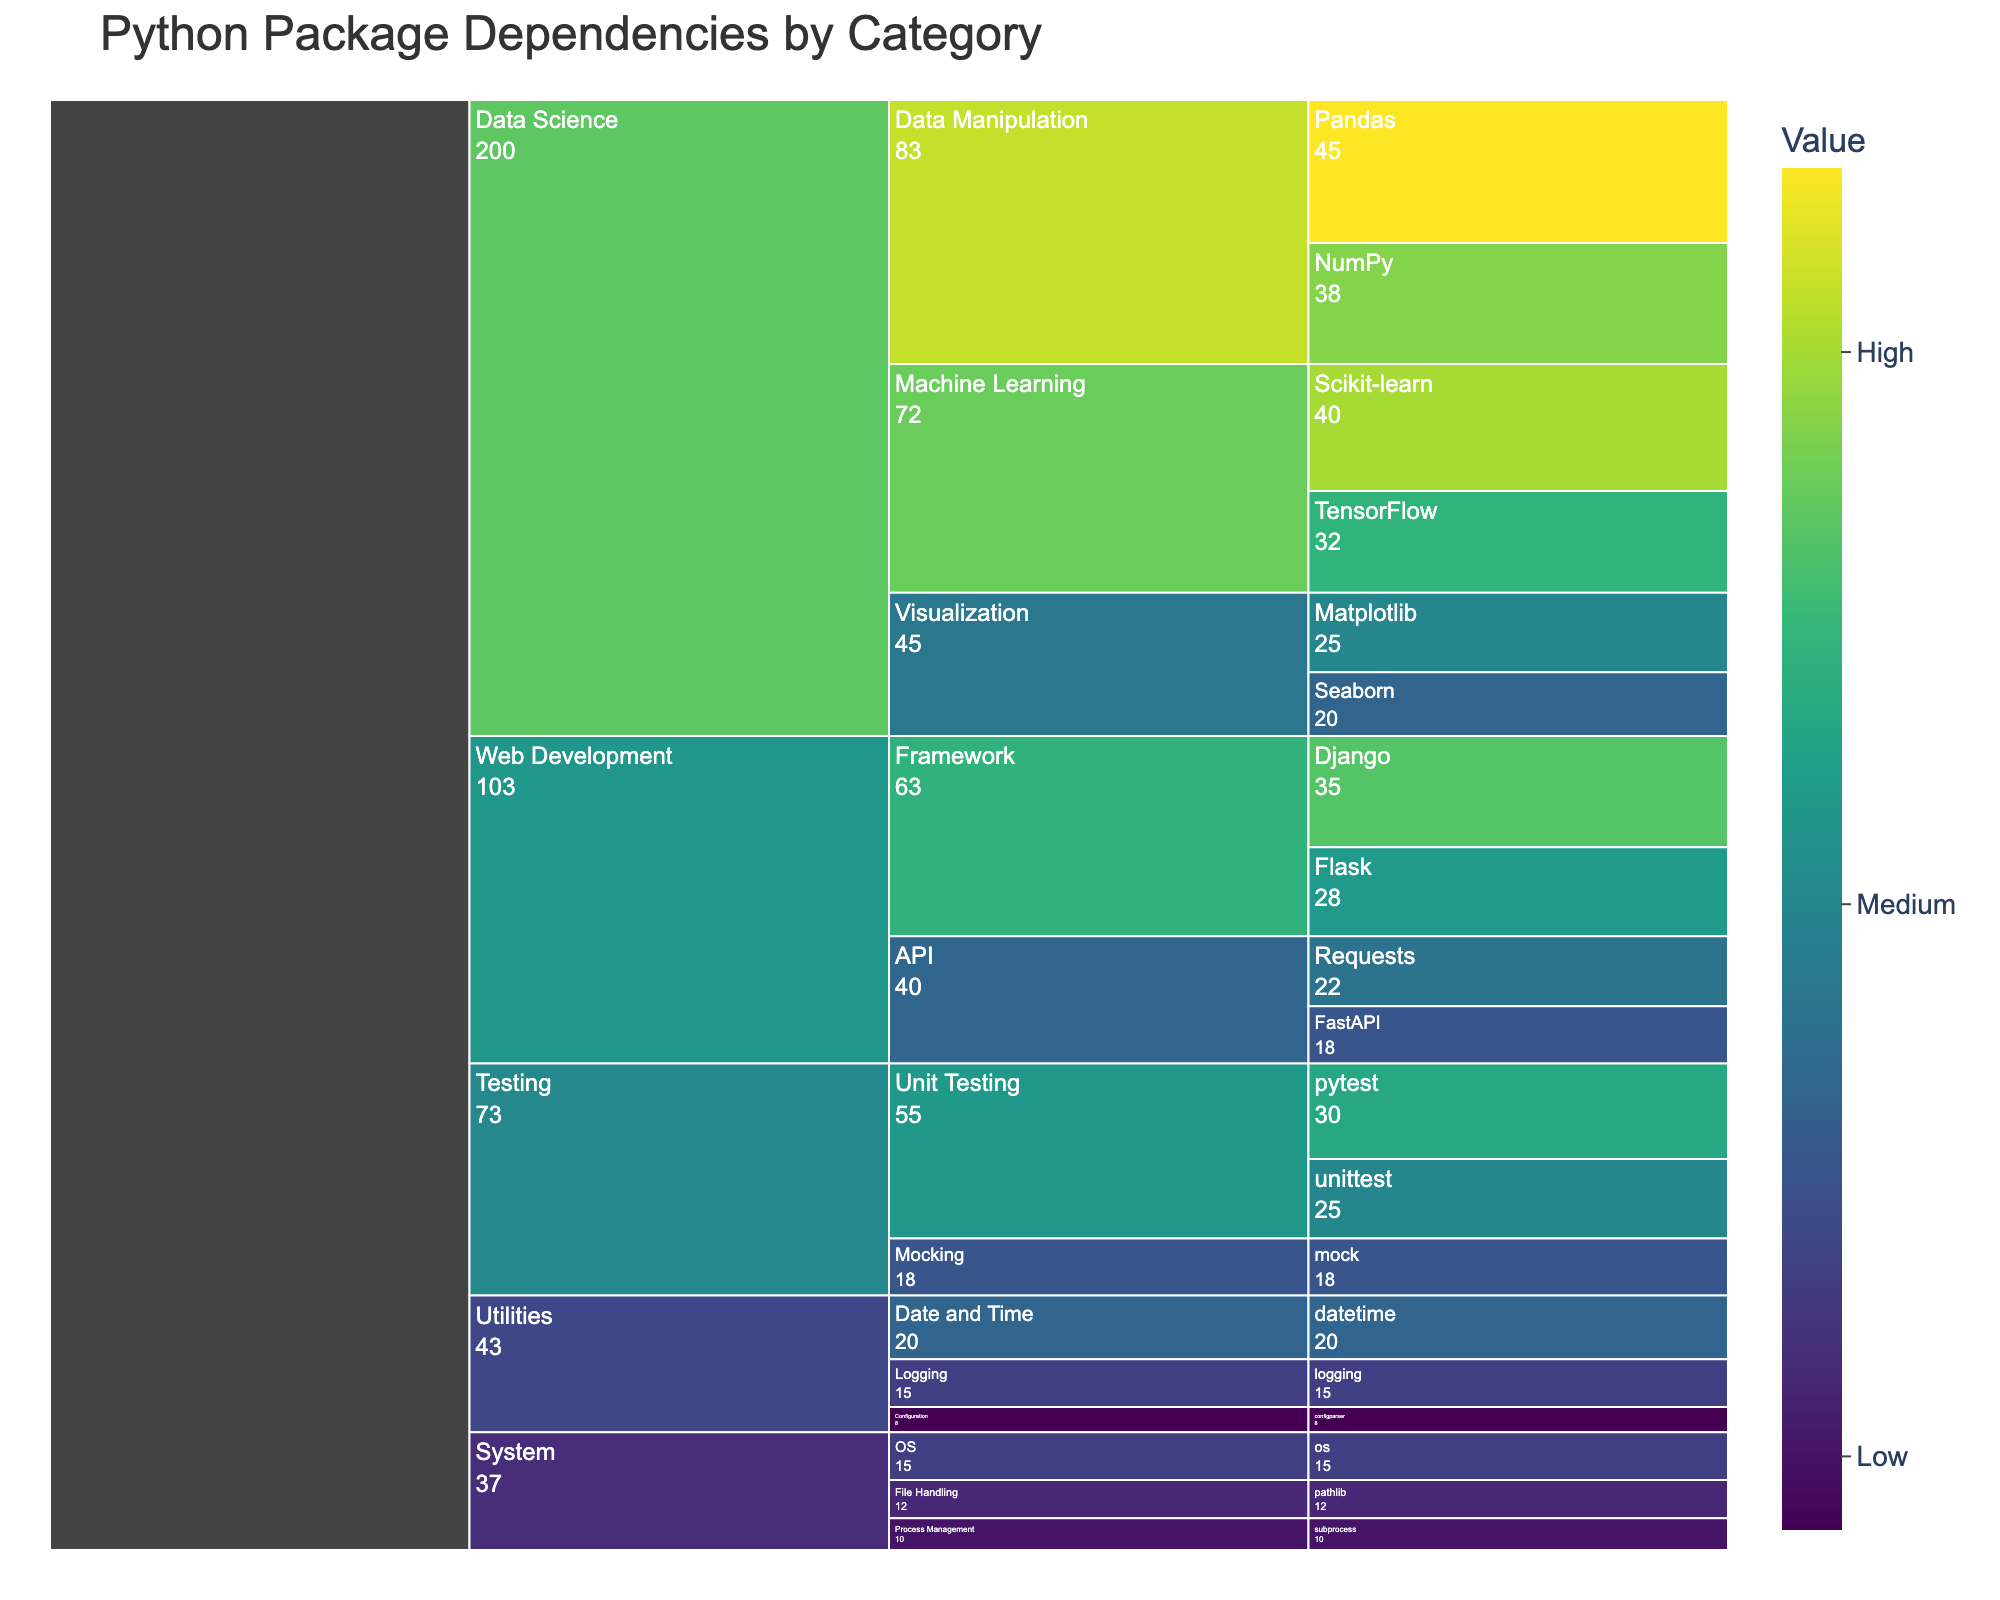What's the title of the chart? The title is usually positioned at the top of the chart and is indicated clearly in larger and bolder font compared to other text elements. In this chart, the title displayed at the top center is 'Python Package Dependencies by Category'.
Answer: Python Package Dependencies by Category Which category has the highest total value? To determine the category with the highest total value, add up the values of all packages within each category and compare the sums. Summing the values for 'Data Science' yields 200, 'Web Development' yields 103, 'System' yields 37, 'Testing' yields 73, and 'Utilities' yields 43. Therefore, 'Data Science' has the highest total value.
Answer: Data Science What is the value for the package 'Django'? Locate the package 'Django' under the 'Framework' subcategory within the 'Web Development' category. The chart indicates that 'Django' has a value of 35.
Answer: 35 Which subcategory within 'Data Science' has the highest total value? To find this, sum the values of packages within each subcategory under 'Data Science'. The subcategories and their total values are: 'Machine Learning' (Scikit-learn + TensorFlow = 40 + 32 = 72), 'Data Manipulation' (Pandas + NumPy = 45 + 38 = 83), and 'Visualization' (Matplotlib + Seaborn = 25 + 20 = 45). The subcategory with the highest value is 'Data Manipulation'.
Answer: Data Manipulation How does the value of 'Flask' compare to 'Requests'? Locate each package under their respective subcategories in 'Web Development'. 'Flask' has a value of 28, and 'Requests' has a value of 22. Therefore, 'Flask' has a higher value than 'Requests'.
Answer: Flask has a higher value What is the total value of all 'Unit Testing' packages in the chart? First, locate the 'Unit Testing' subcategory under 'Testing'. The packages here are 'pytest' with a value of 30 and 'unittest' with a value of 25. Adding these gives 30 + 25 = 55.
Answer: 55 Which subcategory has the smallest value within the 'Utilities' category? To determine this, compare the values of packages within the 'Utilities' subcategories. The subcategories are 'Date and Time' (20), 'Logging' (15), and 'Configuration' (8). The 'Configuration' subcategory has the smallest value.
Answer: Configuration What is the combined total value of the 'API' subcategory in 'Web Development'? Locate the 'API' subcategory in the 'Web Development' category which includes 'FastAPI' (18) and 'Requests' (22). Their combined value is 18 + 22 = 40.
Answer: 40 How does the value of 'Seaborn' compare to 'Matplotlib'? Both packages are under the 'Visualization' subcategory in 'Data Science'. 'Seaborn' has a value of 20, and 'Matplotlib' has a value of 25. Hence, 'Matplotlib' has a higher value than 'Seaborn'.
Answer: Matplotlib has a higher value Calculate the difference in combined values between 'Framework' and 'API' subcategories in 'Web Development'. First, sum the values for each subcategory. 'Framework' includes 'Django' (35) and 'Flask' (28) which together equal 63. 'API' includes 'FastAPI' (18) and 'Requests' (22) which together equal 40. The difference is 63 - 40 = 23.
Answer: 23 